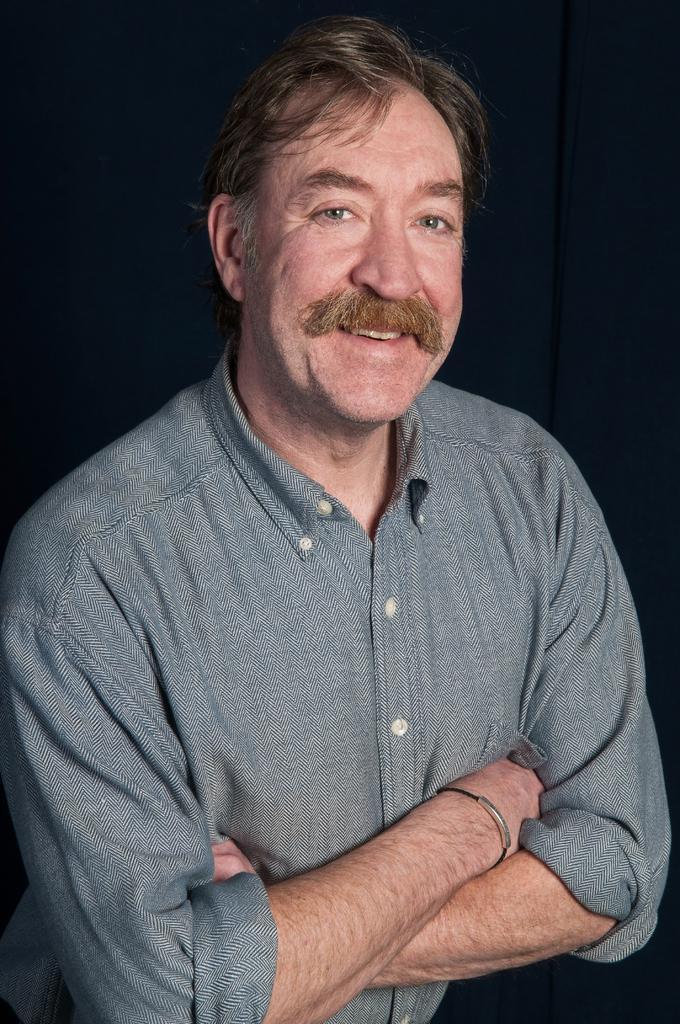In one or two sentences, can you explain what this image depicts? In the center of the image a man is there. In the background of the image curtain is there. 